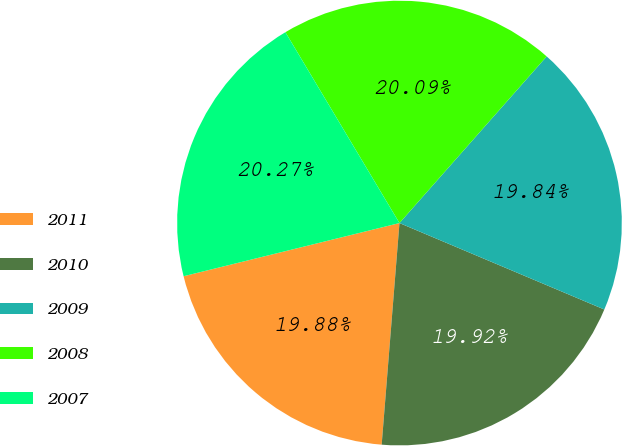Convert chart. <chart><loc_0><loc_0><loc_500><loc_500><pie_chart><fcel>2011<fcel>2010<fcel>2009<fcel>2008<fcel>2007<nl><fcel>19.88%<fcel>19.92%<fcel>19.84%<fcel>20.09%<fcel>20.27%<nl></chart> 